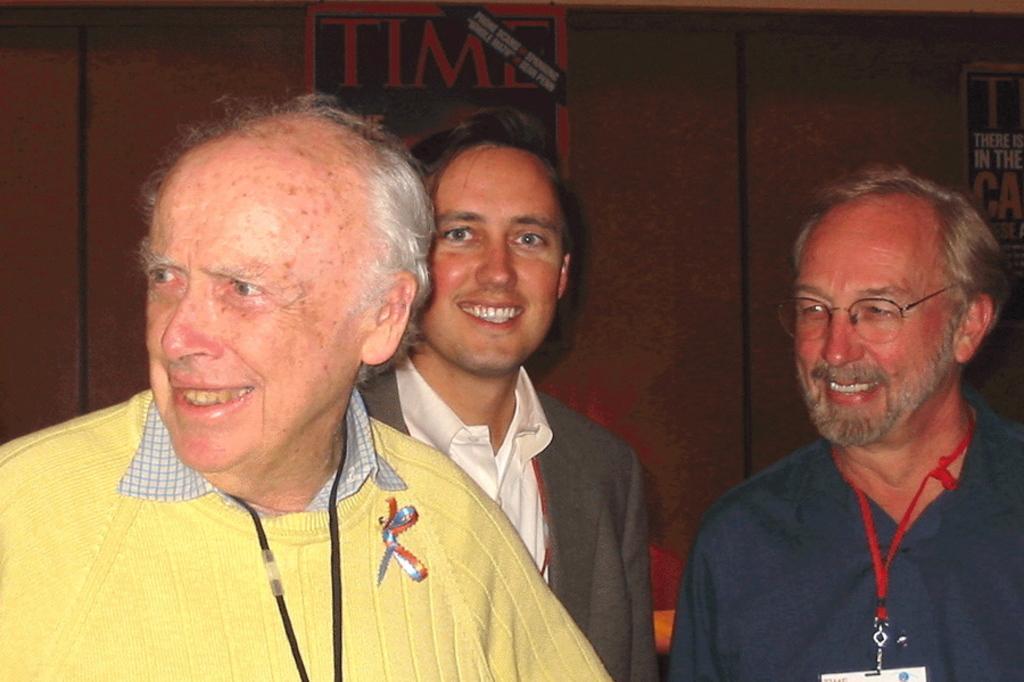Please provide a concise description of this image. On the right of this picture we can see a man wearing spectacles, t-shirt and smiling. On the left we can see a person wearing sweater, smiling and seems to be standing and we can see another person wearing blazer, smiling and seems to be standing. In the background we can see the text on the posters attached to the wall and we can see some other objects. 